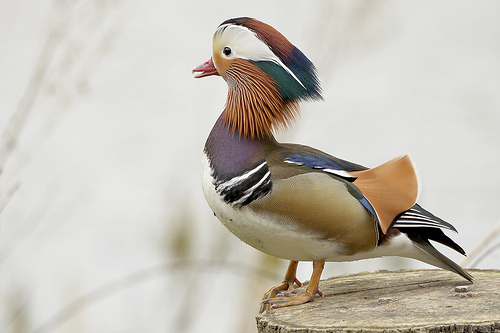<image>
Is the bird above the stump? Yes. The bird is positioned above the stump in the vertical space, higher up in the scene. 